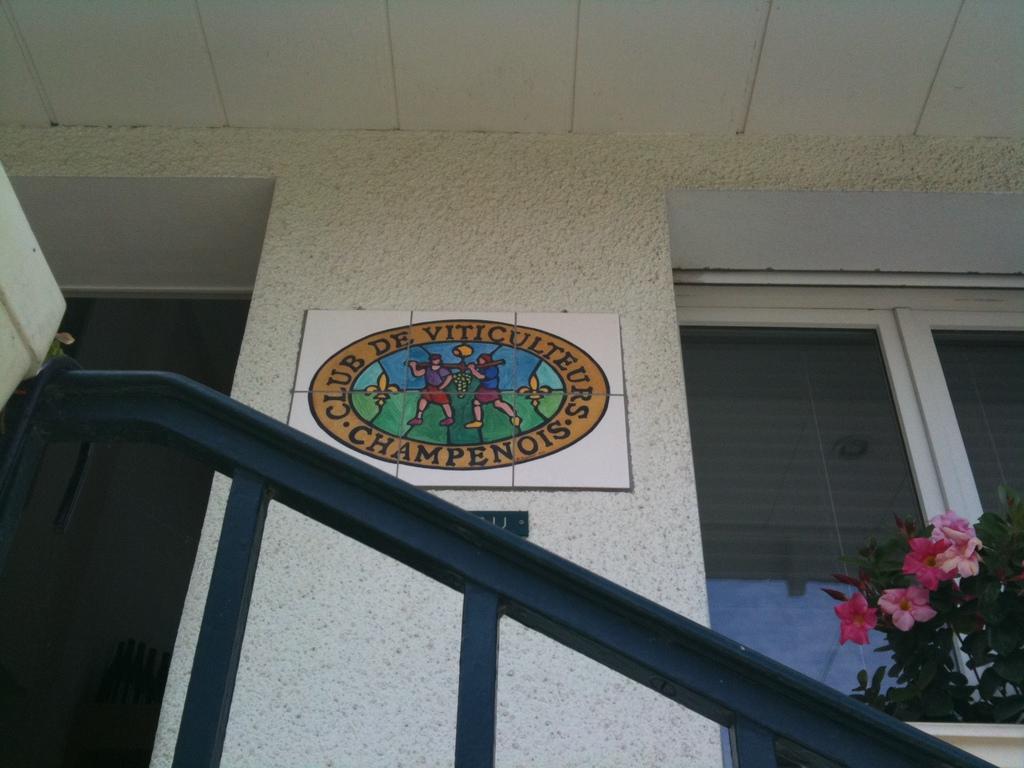Describe this image in one or two sentences. Here we can see a wall, boards, glasses, plants, and flowers. 